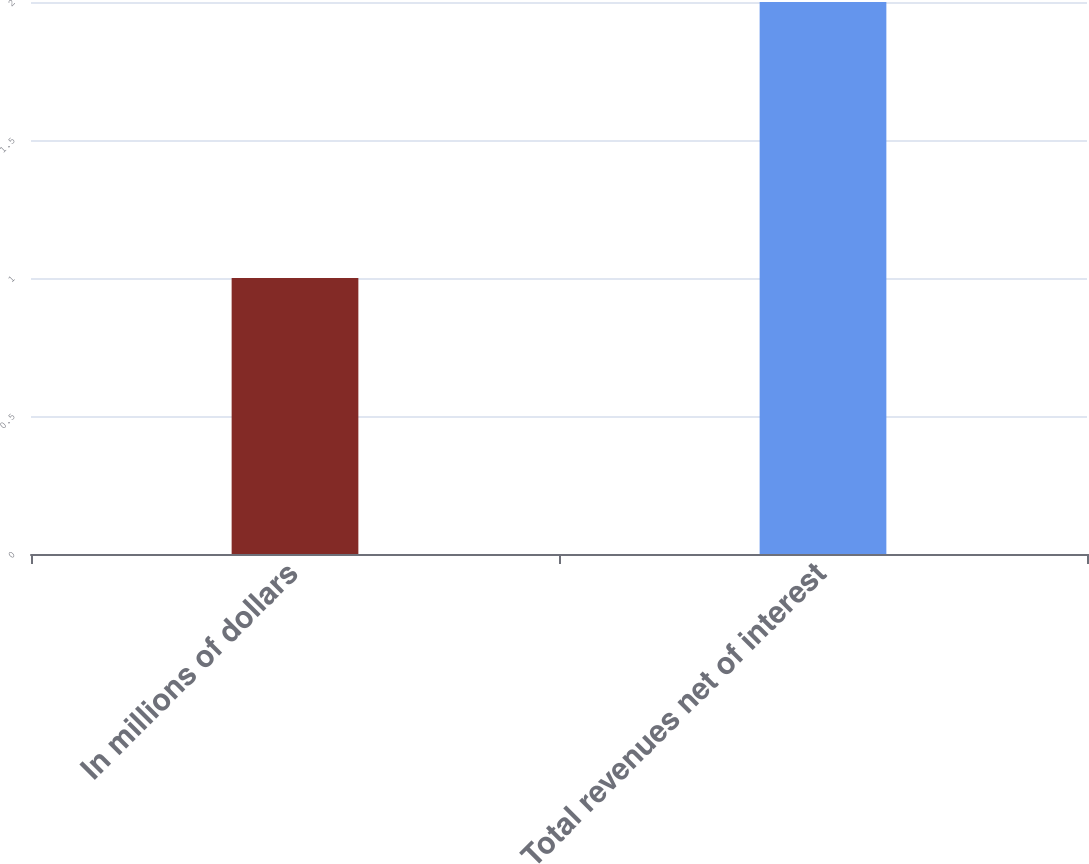Convert chart to OTSL. <chart><loc_0><loc_0><loc_500><loc_500><bar_chart><fcel>In millions of dollars<fcel>Total revenues net of interest<nl><fcel>1<fcel>2<nl></chart> 